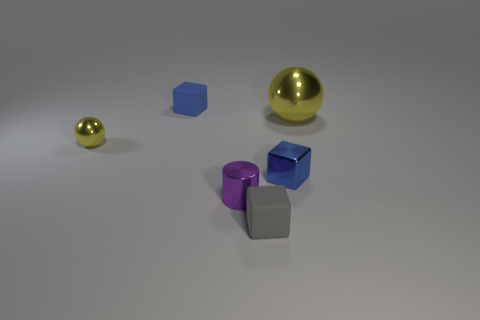Do the large sphere and the small metal ball have the same color?
Your answer should be compact. Yes. How many tiny objects are blue matte blocks or blue things?
Provide a short and direct response. 2. Is there any other thing of the same color as the big metallic ball?
Provide a short and direct response. Yes. There is a small purple thing that is made of the same material as the large yellow object; what is its shape?
Offer a terse response. Cylinder. There is a ball on the right side of the small purple shiny object; what size is it?
Offer a very short reply. Large. The gray thing is what shape?
Your response must be concise. Cube. There is a yellow ball that is right of the tiny blue matte cube; is it the same size as the yellow metal object to the left of the blue metal block?
Give a very brief answer. No. There is a yellow object that is in front of the yellow object on the right side of the matte object behind the small ball; how big is it?
Provide a short and direct response. Small. There is a tiny rubber object that is left of the small matte thing in front of the yellow shiny thing that is on the right side of the tiny gray matte object; what is its shape?
Keep it short and to the point. Cube. There is a matte object behind the small shiny sphere; what is its shape?
Keep it short and to the point. Cube. 